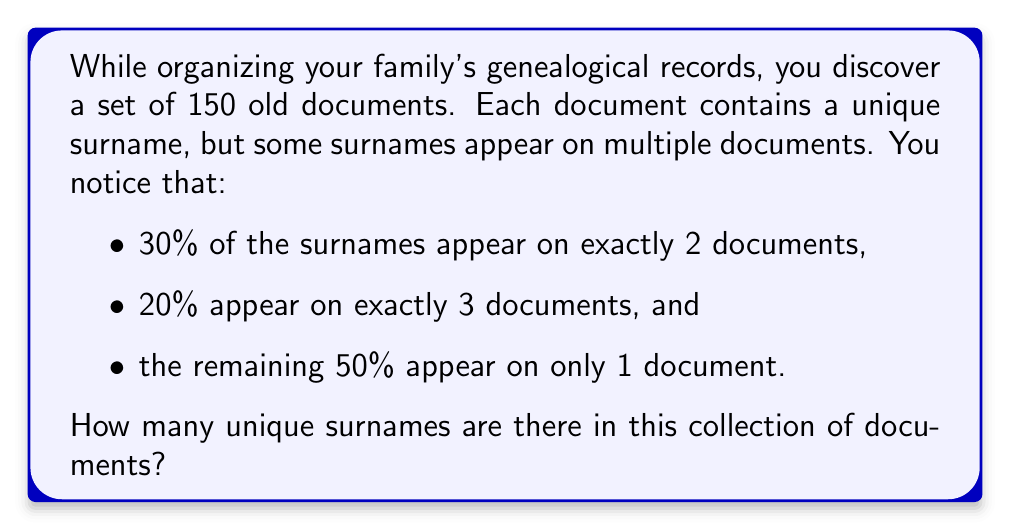Could you help me with this problem? Let's approach this step-by-step:

1) Let $x$ be the number of unique surnames.

2) We can break down the 150 documents based on how many times each surname appears:
   - 50% of $x$ surnames appear once: $0.5x \cdot 1 = 0.5x$
   - 30% of $x$ surnames appear twice: $0.3x \cdot 2 = 0.6x$
   - 20% of $x$ surnames appear thrice: $0.2x \cdot 3 = 0.6x$

3) The sum of these should equal the total number of documents:

   $$0.5x + 0.6x + 0.6x = 150$$

4) Simplify the left side of the equation:

   $$1.7x = 150$$

5) Solve for $x$:

   $$x = \frac{150}{1.7} \approx 88.2353$$

6) Since we can't have a fractional number of surnames, we round down to the nearest whole number.
Answer: 88 